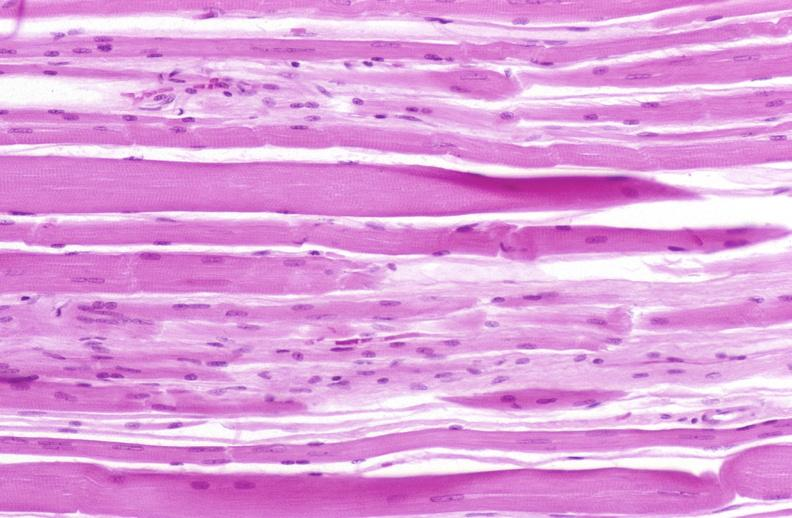what is present?
Answer the question using a single word or phrase. Soft tissue 